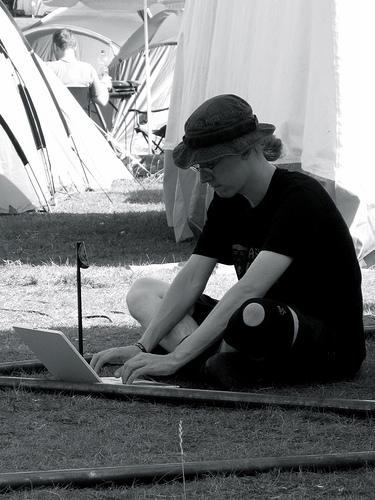What is on the man's head?
Concise answer only. Hat. What is the man doing?
Give a very brief answer. Typing. What color is the photo?
Write a very short answer. Black and white. 